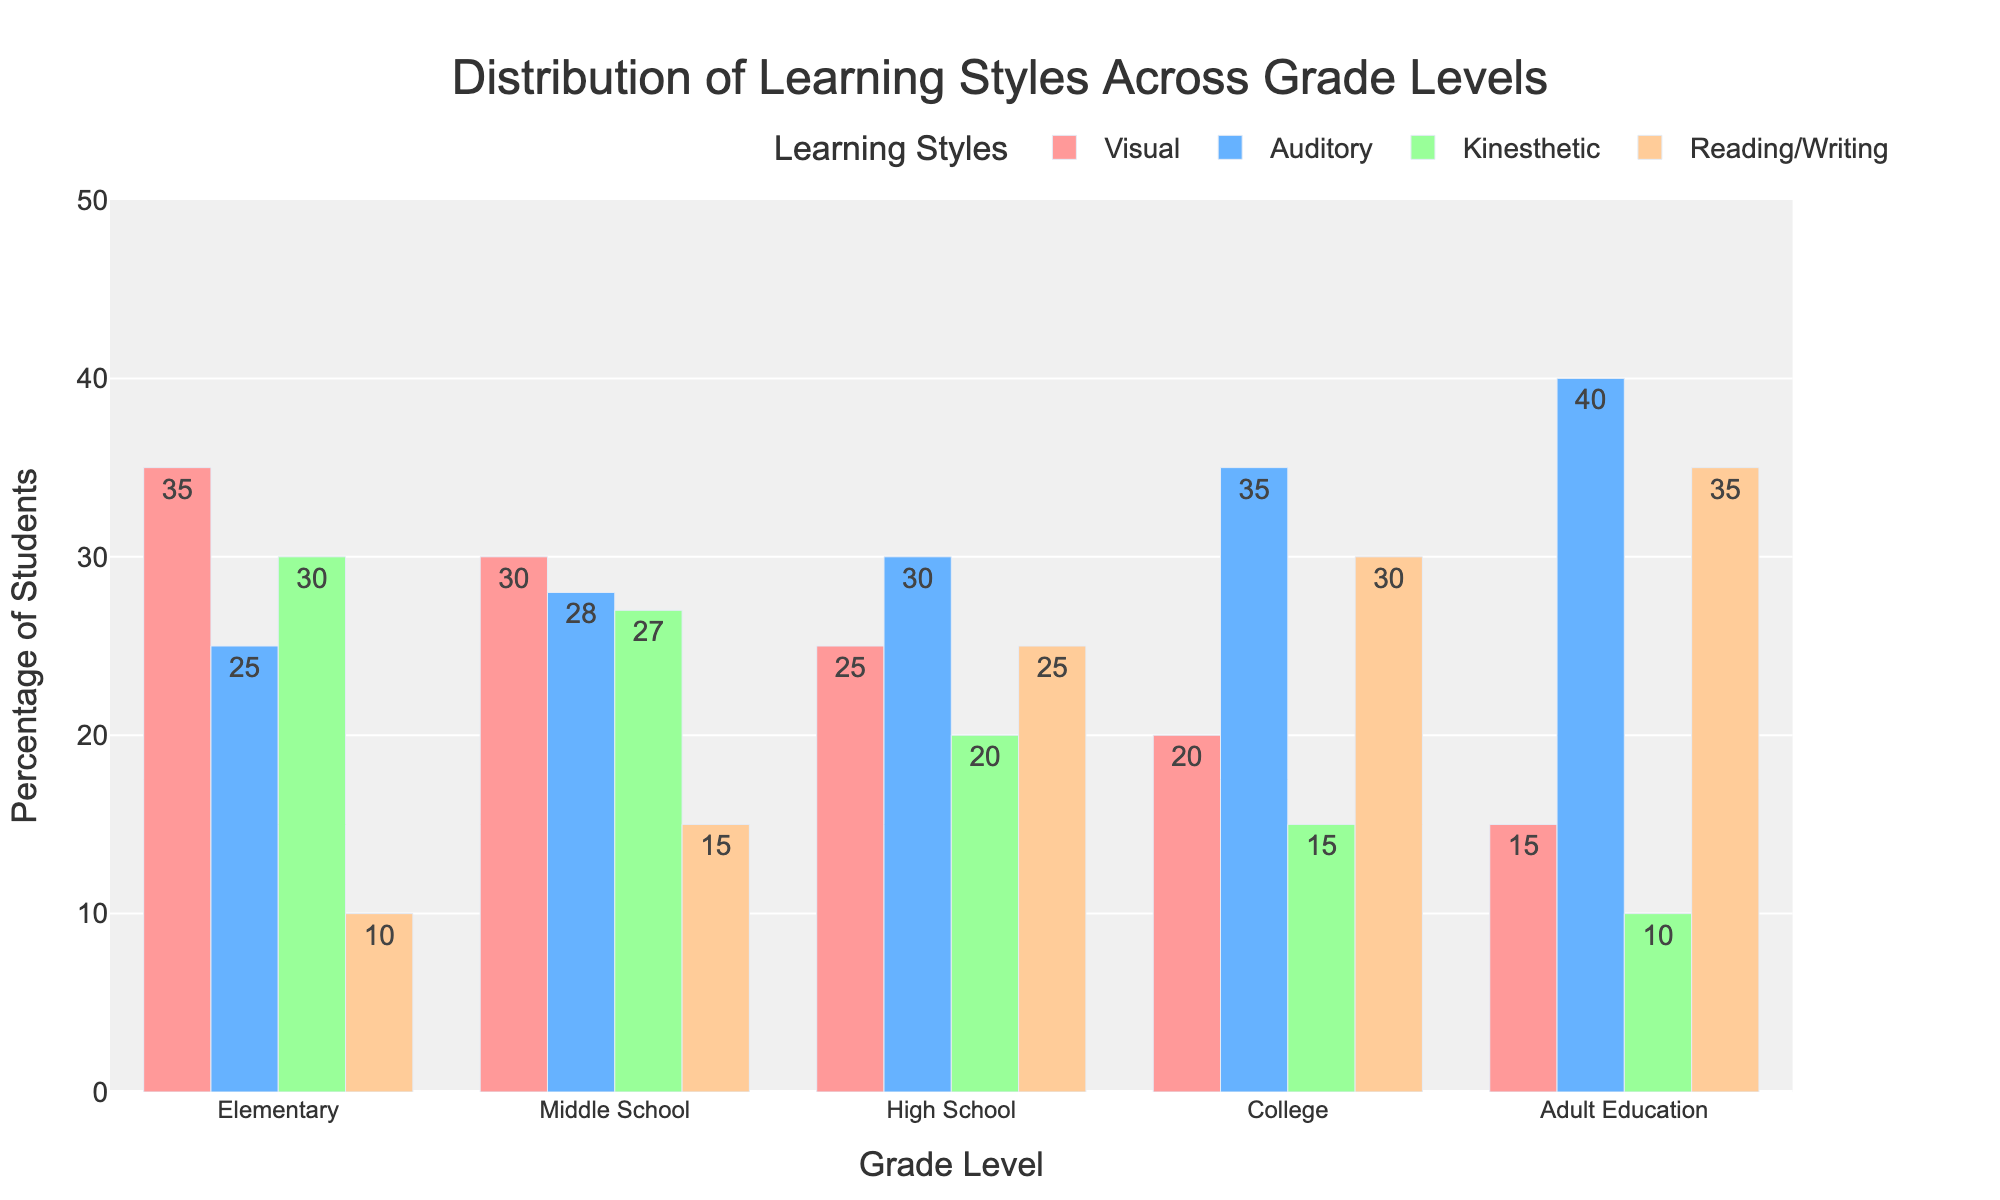Which grade level has the highest percentage of Visual learners? The highest bar for Visual learning style corresponds to the Elementary grade level.
Answer: Elementary How does the percentage of Kinesthetic learners in Middle School compare to that in High School? The bar for Kinesthetic learners in Middle School is higher than that in High School (27 vs. 20).
Answer: Higher What is the average percentage of students with an Auditory learning style across all grade levels? Summing the percentages for Auditory learners: (25 + 28 + 30 + 35 + 40) gives 158. The average is 158/5 = 31.6.
Answer: 31.6 Which grade level has the smallest percentage of Reading/Writing learners? The shortest bar for Reading/Writing learning style corresponds to the Elementary grade level.
Answer: Elementary How much does the percentage of Visual learners decrease from Elementary to Adult Education? The percentage of Visual learners in Elementary is 35% and in Adult Education is 15%. The decrease is 35 - 15 = 20%.
Answer: 20% If you sum the percentages of Kinesthetic and Reading/Writing learners for College, does it exceed the percentage of Auditory learners for the same grade level? The sum of Kinesthetic (15%) and Reading/Writing (30%) learners for College is 45%. The percentage of Auditory learners is 35%, so 45% exceeds 35%.
Answer: Yes Which grade level has a higher percentage of students who use Auditory learning compared to Visual learning, and by how much? For College, the percentage of Auditory learners is 35% and Visual learners is 20%, indicating a higher percentage for Auditory learners by 35 - 20 = 15%.
Answer: College, 15% Across all grade levels, which learning style has the greatest total percentage? Summing the percentages for each learning style across all grade levels: 
Visual (35+30+25+20+15) = 125,
Auditory (25+28+30+35+40) = 158,
Kinesthetic (30+27+20+15+10) = 102,
Reading/Writing (10+15+25+30+35) = 115.
Auditory has the greatest total percentage of 158.
Answer: Auditory By how much does the percentage of Reading/Writing learners increase from Elementary to High School? The percentage of Reading/Writing learners in Elementary is 10% and in High School is 25%. The increase is 25 - 10 = 15%.
Answer: 15% Among the different grade levels, which one has the lowest combined percentage for Visual and Kinesthetic learners? Calculating the combined percentage for Visual and Kinesthetic learners:
Elementary: 35+30=65,
Middle School: 30+27=57,
High School: 25+20=45,
College: 20+15=35,
Adult Education: 15+10=25.
Adult Education has the lowest combined percentage of 25.
Answer: Adult Education 